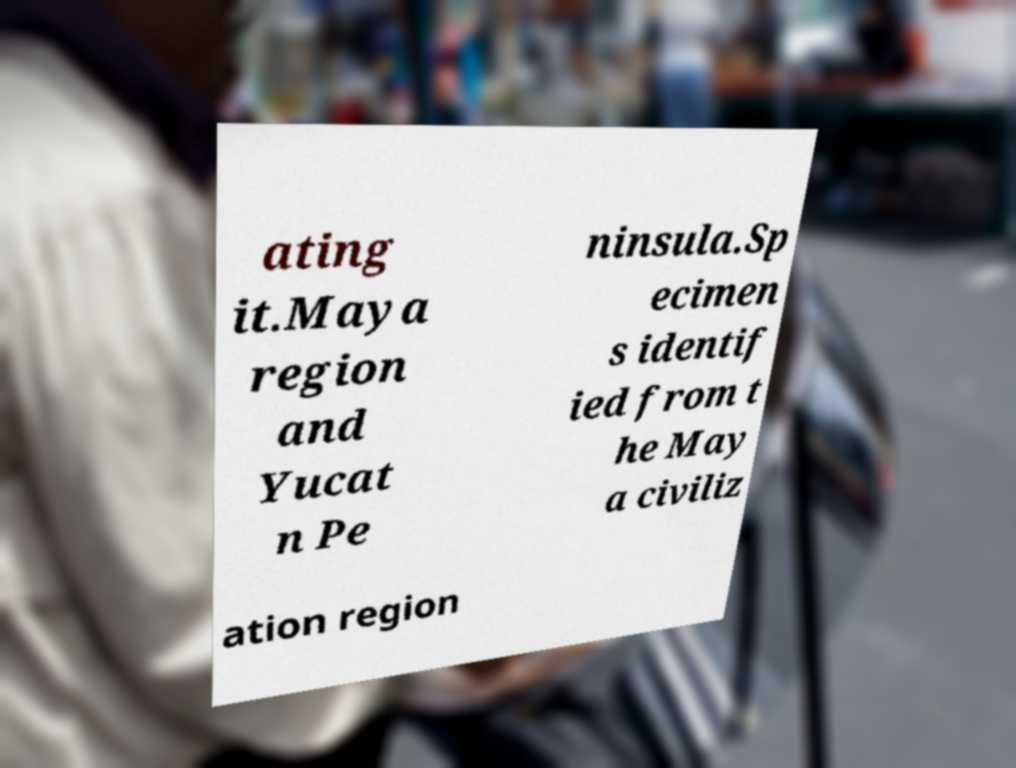Please identify and transcribe the text found in this image. ating it.Maya region and Yucat n Pe ninsula.Sp ecimen s identif ied from t he May a civiliz ation region 